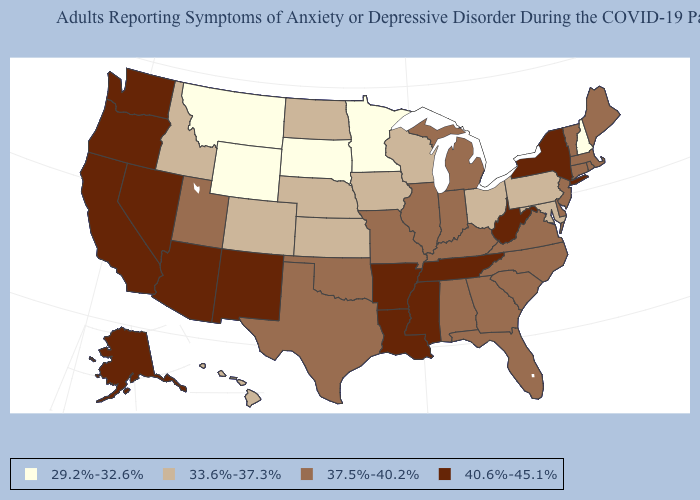Does Oregon have the highest value in the USA?
Be succinct. Yes. Which states have the highest value in the USA?
Answer briefly. Alaska, Arizona, Arkansas, California, Louisiana, Mississippi, Nevada, New Mexico, New York, Oregon, Tennessee, Washington, West Virginia. Among the states that border New Mexico , does Colorado have the lowest value?
Keep it brief. Yes. What is the value of Tennessee?
Short answer required. 40.6%-45.1%. What is the highest value in the Northeast ?
Short answer required. 40.6%-45.1%. What is the value of New Jersey?
Be succinct. 37.5%-40.2%. Does Louisiana have a higher value than Oregon?
Concise answer only. No. What is the lowest value in the USA?
Give a very brief answer. 29.2%-32.6%. Name the states that have a value in the range 37.5%-40.2%?
Answer briefly. Alabama, Connecticut, Delaware, Florida, Georgia, Illinois, Indiana, Kentucky, Maine, Massachusetts, Michigan, Missouri, New Jersey, North Carolina, Oklahoma, Rhode Island, South Carolina, Texas, Utah, Vermont, Virginia. What is the value of Iowa?
Be succinct. 33.6%-37.3%. What is the value of Virginia?
Be succinct. 37.5%-40.2%. Among the states that border Vermont , which have the highest value?
Give a very brief answer. New York. What is the value of Rhode Island?
Give a very brief answer. 37.5%-40.2%. What is the lowest value in the Northeast?
Answer briefly. 29.2%-32.6%. Does New Jersey have the highest value in the Northeast?
Be succinct. No. 